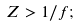Convert formula to latex. <formula><loc_0><loc_0><loc_500><loc_500>Z > 1 / f ;</formula> 